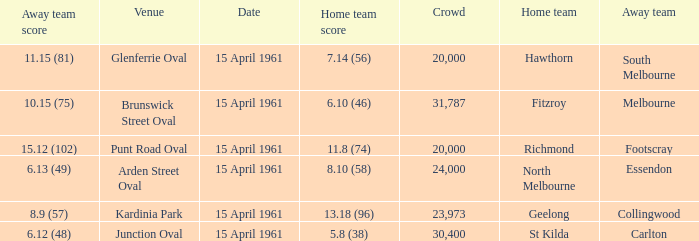Which venue had a home team score of 6.10 (46)? Brunswick Street Oval. 